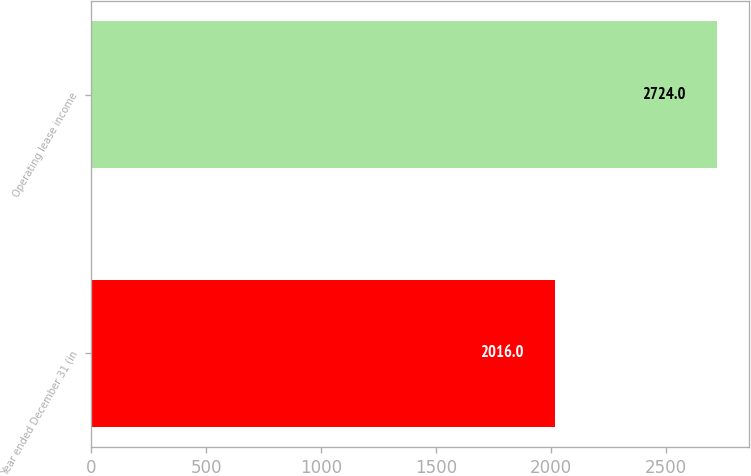<chart> <loc_0><loc_0><loc_500><loc_500><bar_chart><fcel>Year ended December 31 (in<fcel>Operating lease income<nl><fcel>2016<fcel>2724<nl></chart> 